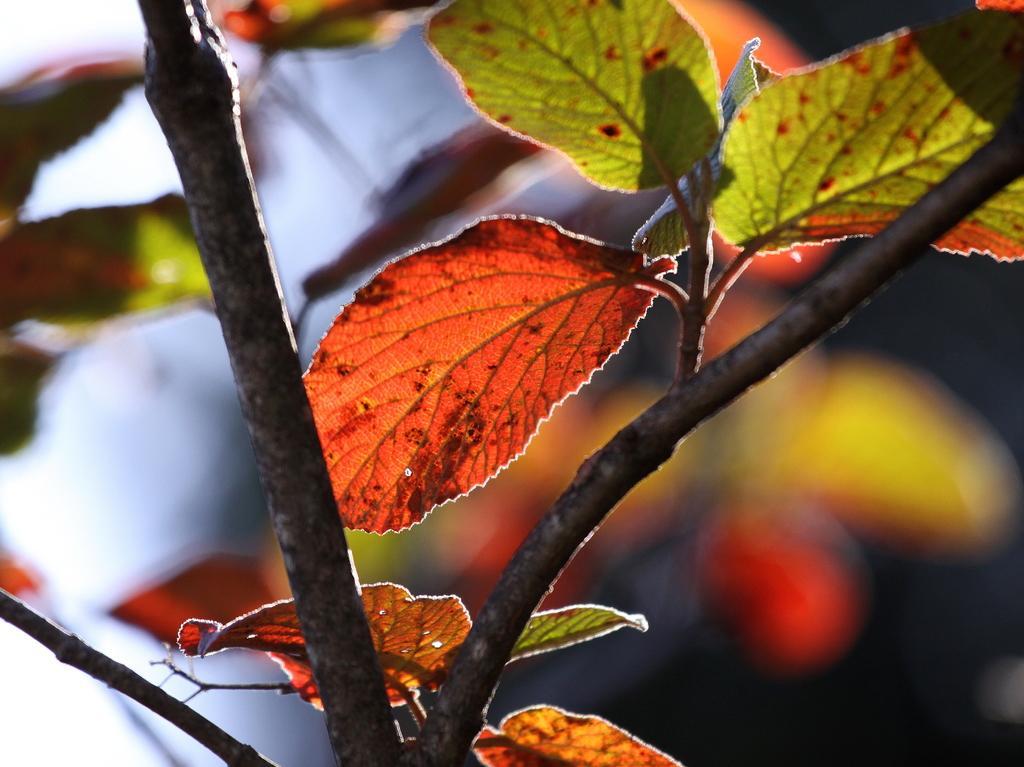Please provide a concise description of this image. In this image I can see trees. This image is taken may be during a day. 